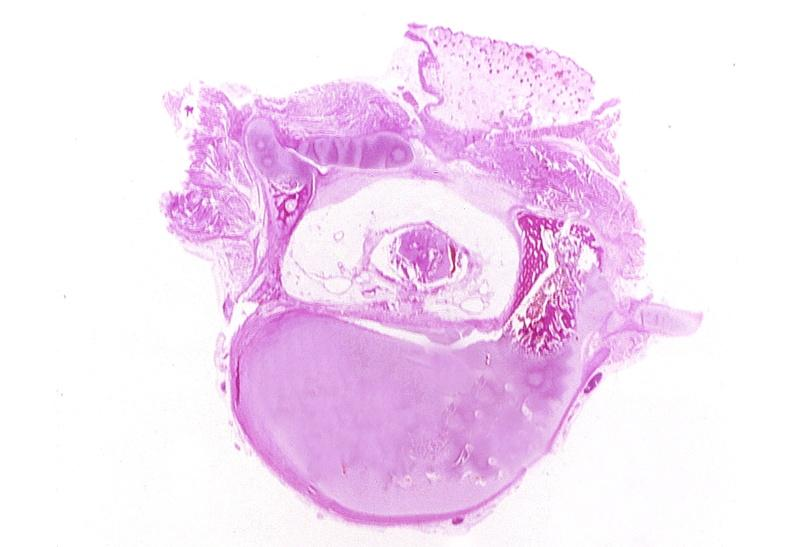what is present?
Answer the question using a single word or phrase. Nervous 